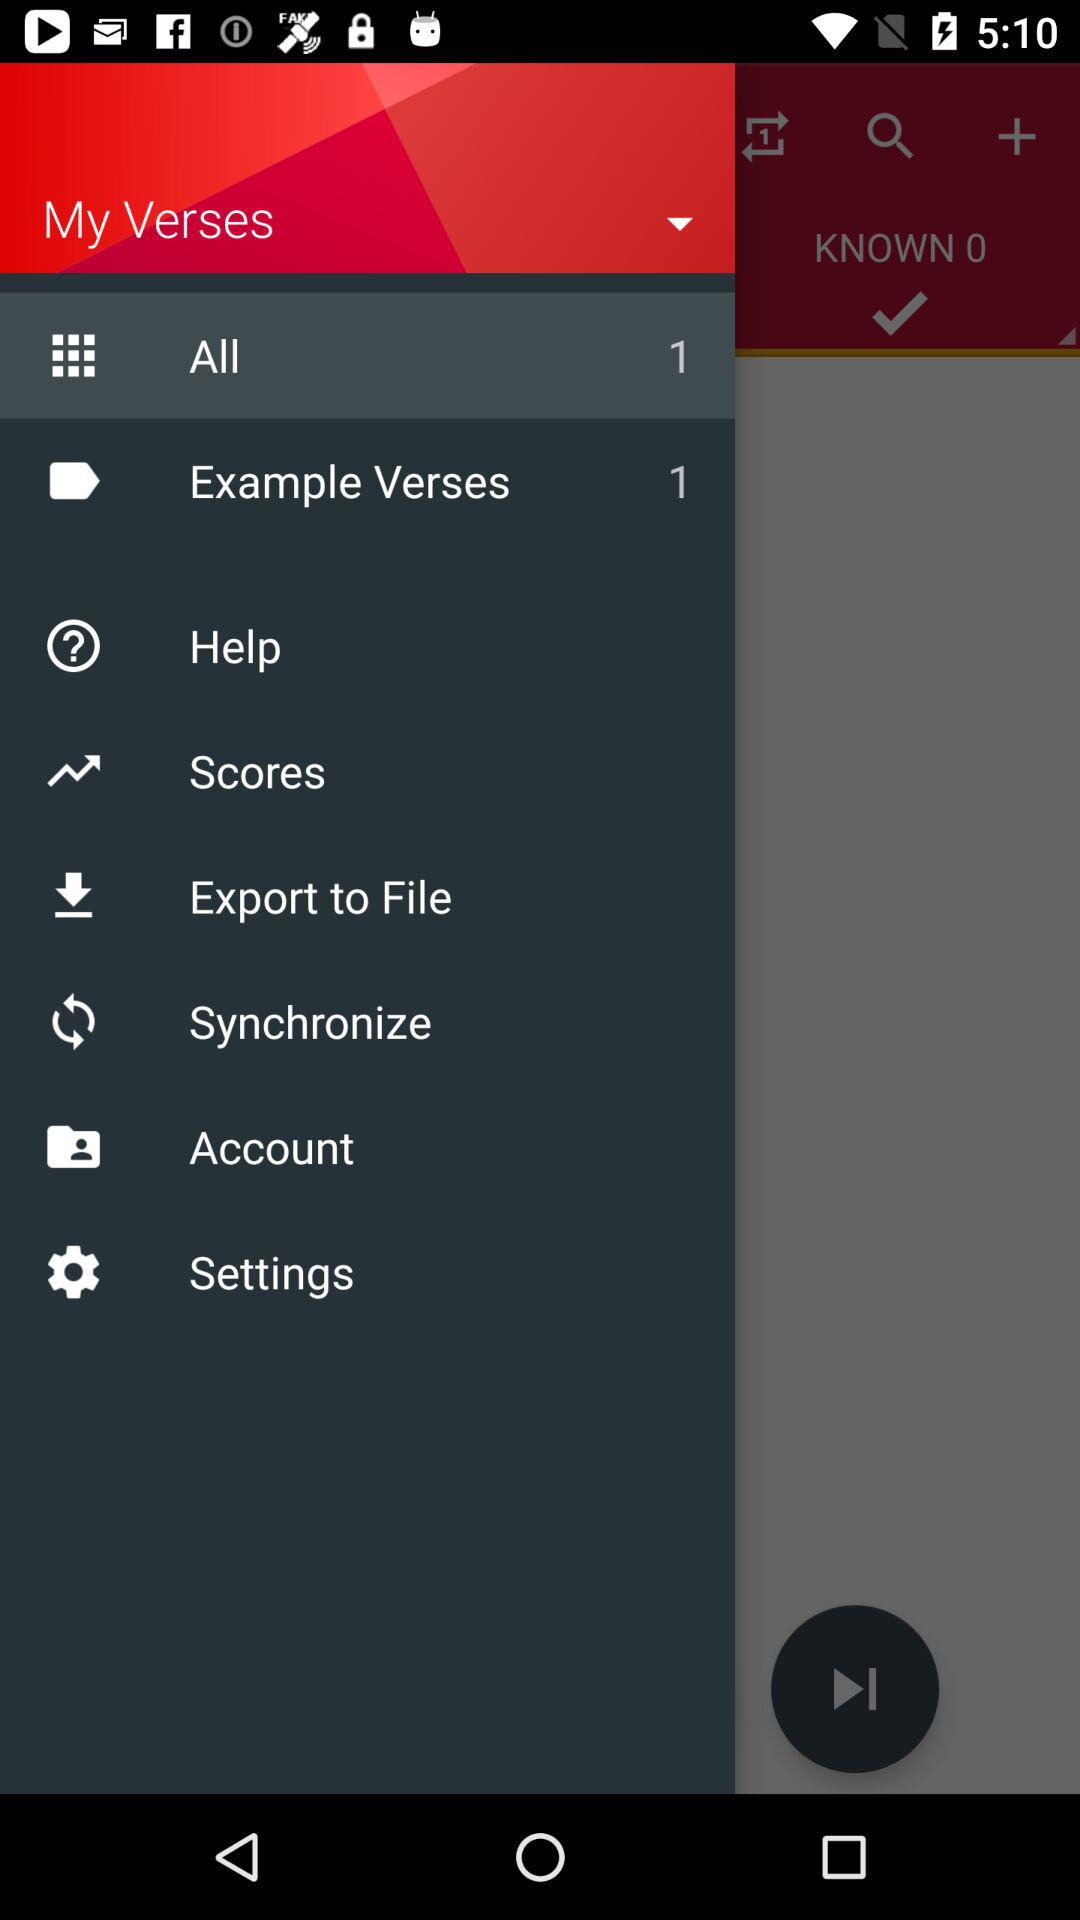How many unread notifications are there in the "Example Verses" item? There is 1 unread notification in the "Example Verses" item. 